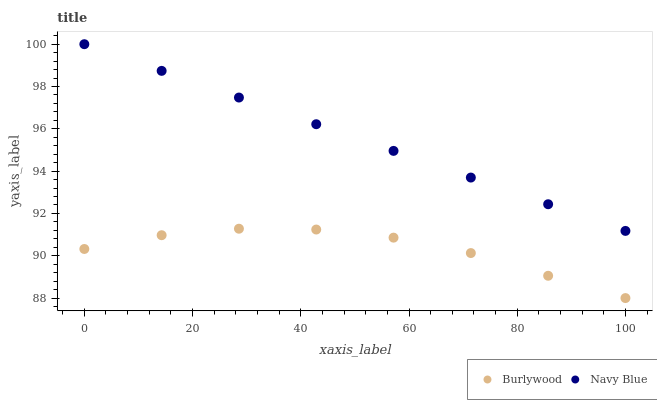Does Burlywood have the minimum area under the curve?
Answer yes or no. Yes. Does Navy Blue have the maximum area under the curve?
Answer yes or no. Yes. Does Navy Blue have the minimum area under the curve?
Answer yes or no. No. Is Navy Blue the smoothest?
Answer yes or no. Yes. Is Burlywood the roughest?
Answer yes or no. Yes. Is Navy Blue the roughest?
Answer yes or no. No. Does Burlywood have the lowest value?
Answer yes or no. Yes. Does Navy Blue have the lowest value?
Answer yes or no. No. Does Navy Blue have the highest value?
Answer yes or no. Yes. Is Burlywood less than Navy Blue?
Answer yes or no. Yes. Is Navy Blue greater than Burlywood?
Answer yes or no. Yes. Does Burlywood intersect Navy Blue?
Answer yes or no. No. 